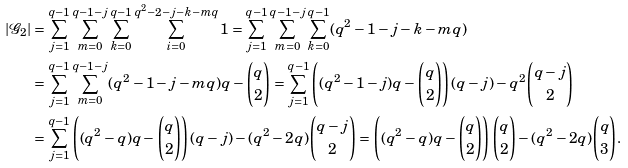<formula> <loc_0><loc_0><loc_500><loc_500>| \mathcal { G } _ { 2 } | & = \sum _ { j = 1 } ^ { q - 1 } \sum _ { m = 0 } ^ { q - 1 - j } \sum _ { k = 0 } ^ { q - 1 } \sum _ { i = 0 } ^ { q ^ { 2 } - 2 - j - k - m q } 1 = \sum _ { j = 1 } ^ { q - 1 } \sum _ { m = 0 } ^ { q - 1 - j } \sum _ { k = 0 } ^ { q - 1 } ( q ^ { 2 } - 1 - j - k - m q ) \\ & = \sum _ { j = 1 } ^ { q - 1 } \sum _ { m = 0 } ^ { q - 1 - j } ( q ^ { 2 } - 1 - j - m q ) q - \binom { q } { 2 } = \sum _ { j = 1 } ^ { q - 1 } \left ( ( q ^ { 2 } - 1 - j ) q - \binom { q } { 2 } \right ) ( q - j ) - q ^ { 2 } \binom { q - j } { 2 } \\ & = \sum _ { j = 1 } ^ { q - 1 } \left ( ( q ^ { 2 } - q ) q - \binom { q } { 2 } \right ) ( q - j ) - ( q ^ { 2 } - 2 q ) \binom { q - j } { 2 } = \left ( ( q ^ { 2 } - q ) q - \binom { q } { 2 } \right ) \binom { q } { 2 } - ( q ^ { 2 } - 2 q ) \binom { q } { 3 } .</formula> 